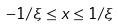Convert formula to latex. <formula><loc_0><loc_0><loc_500><loc_500>- 1 / \xi \leq x \leq 1 / \xi</formula> 